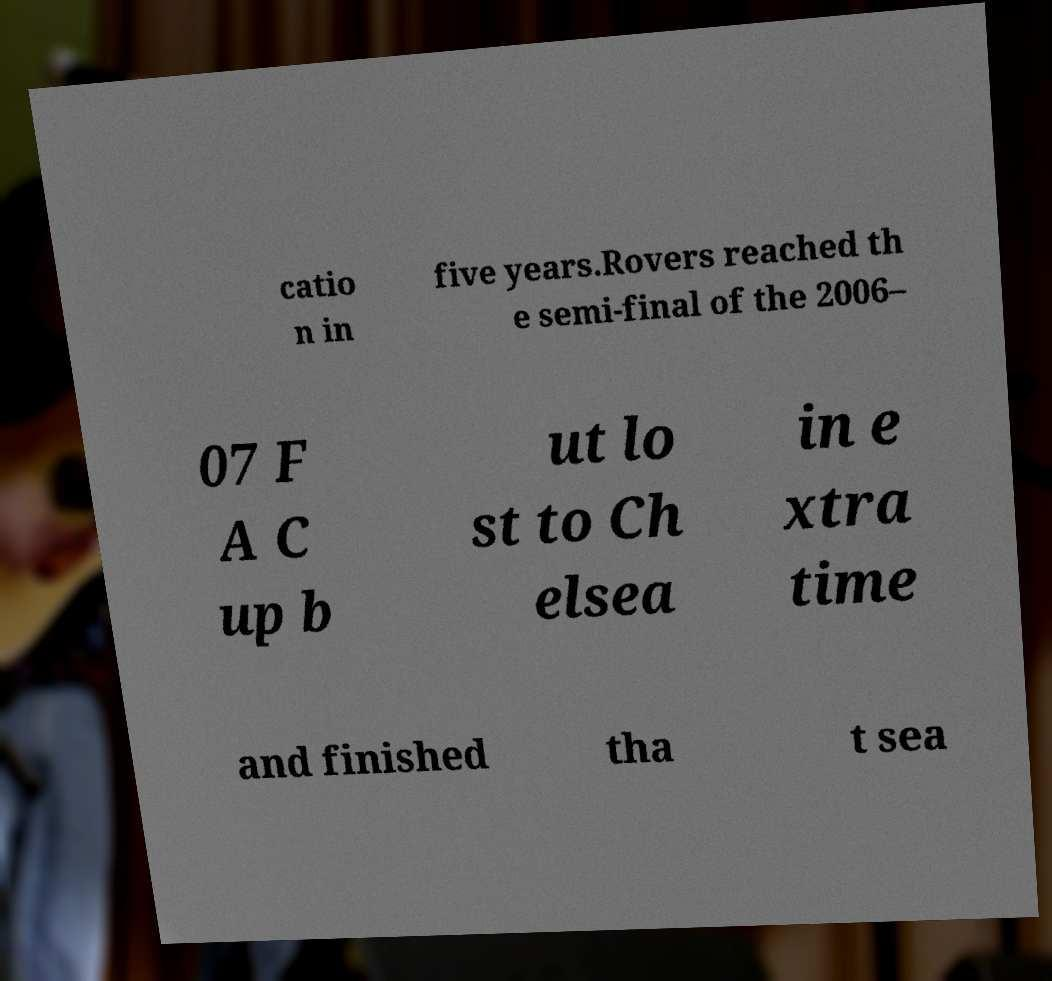Could you assist in decoding the text presented in this image and type it out clearly? catio n in five years.Rovers reached th e semi-final of the 2006– 07 F A C up b ut lo st to Ch elsea in e xtra time and finished tha t sea 